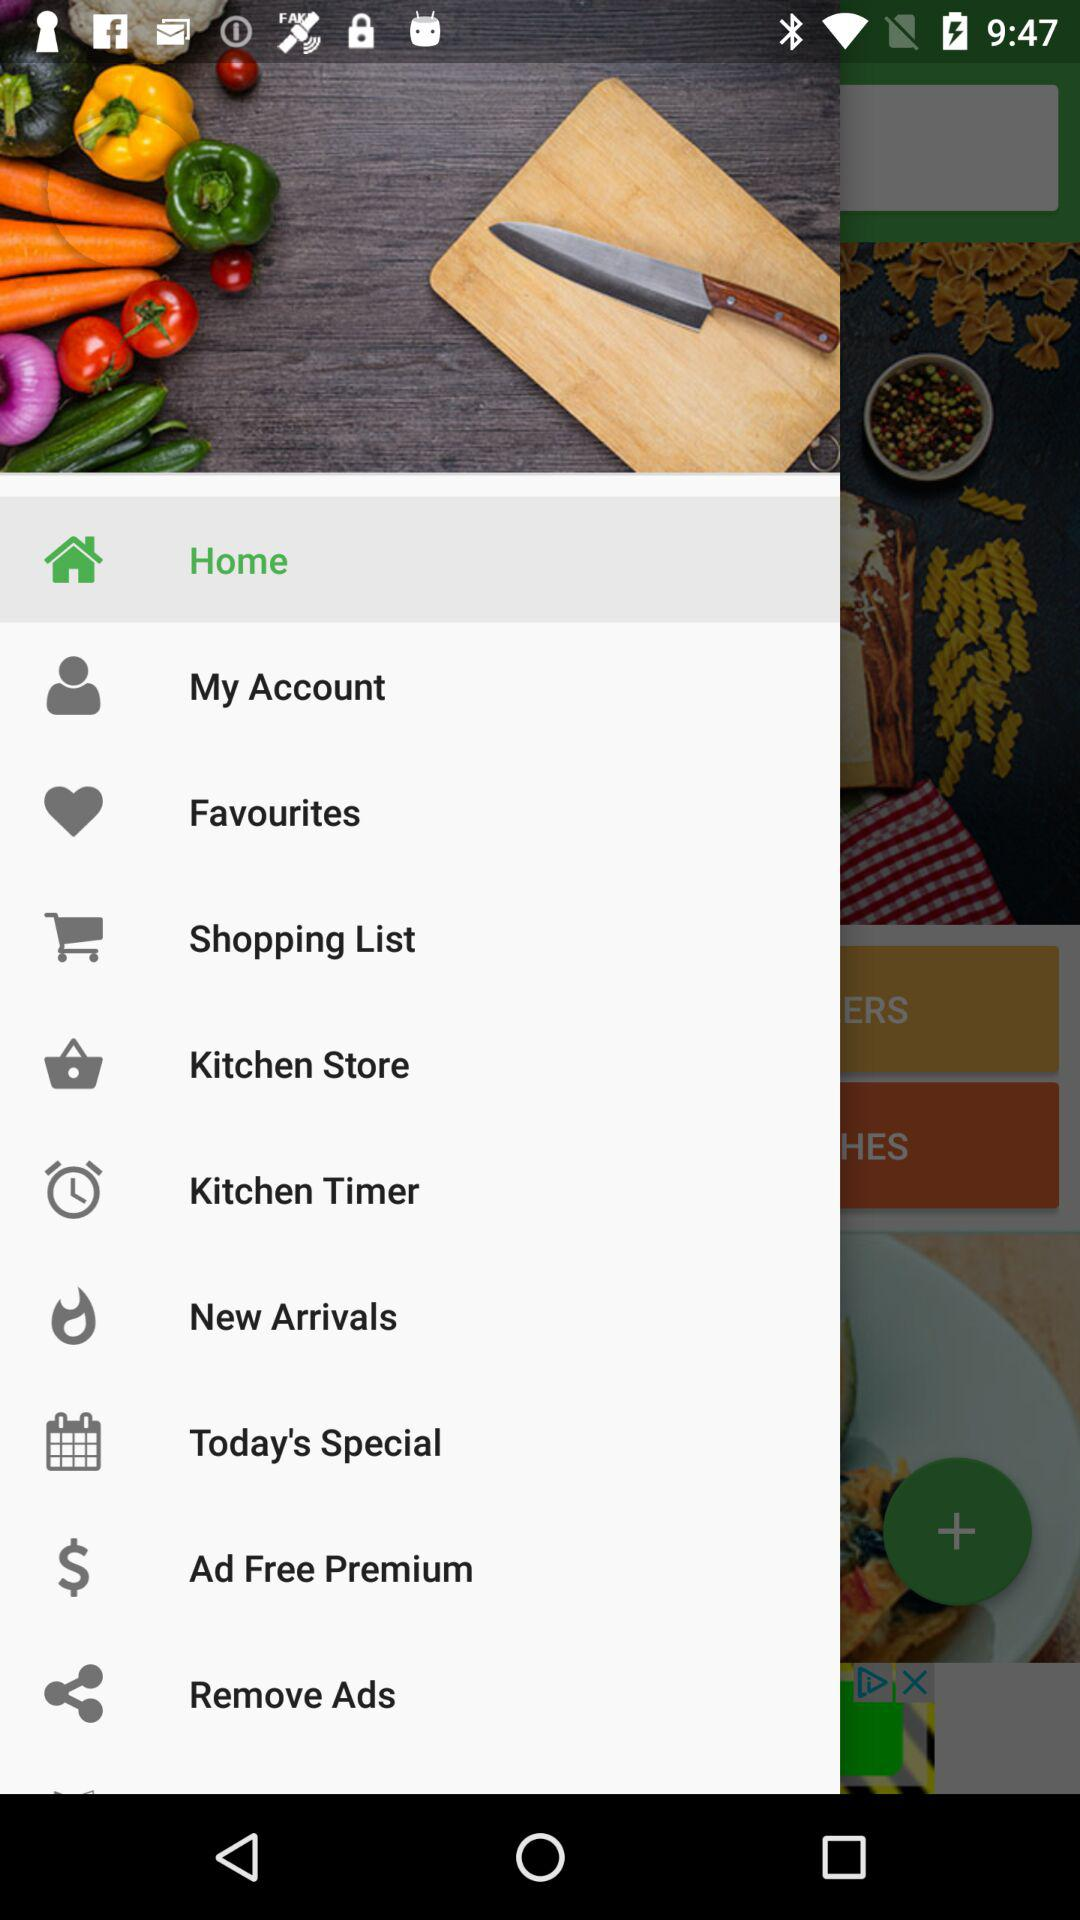Which item is selected? The selected item is "Home". 